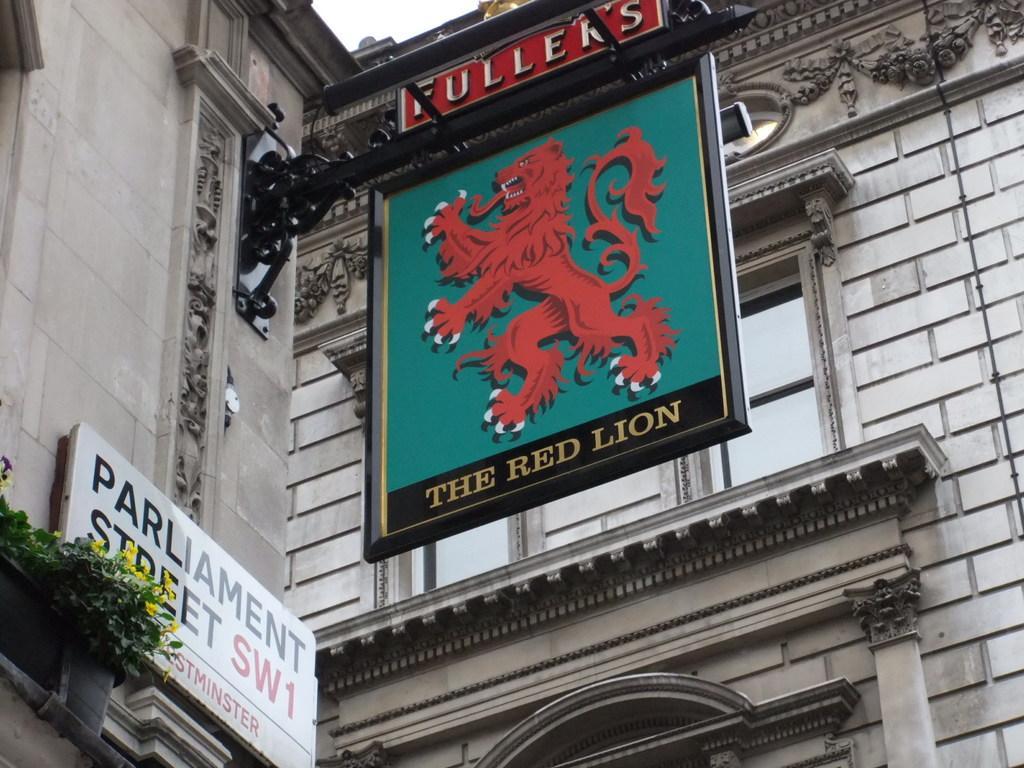Please provide a concise description of this image. This picture is clicked outside and we can see the the text and some pictures on the boards and we can see the green leaves, flowers and the building and some other items. 